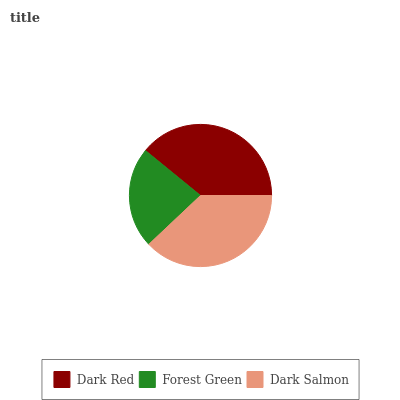Is Forest Green the minimum?
Answer yes or no. Yes. Is Dark Red the maximum?
Answer yes or no. Yes. Is Dark Salmon the minimum?
Answer yes or no. No. Is Dark Salmon the maximum?
Answer yes or no. No. Is Dark Salmon greater than Forest Green?
Answer yes or no. Yes. Is Forest Green less than Dark Salmon?
Answer yes or no. Yes. Is Forest Green greater than Dark Salmon?
Answer yes or no. No. Is Dark Salmon less than Forest Green?
Answer yes or no. No. Is Dark Salmon the high median?
Answer yes or no. Yes. Is Dark Salmon the low median?
Answer yes or no. Yes. Is Dark Red the high median?
Answer yes or no. No. Is Forest Green the low median?
Answer yes or no. No. 